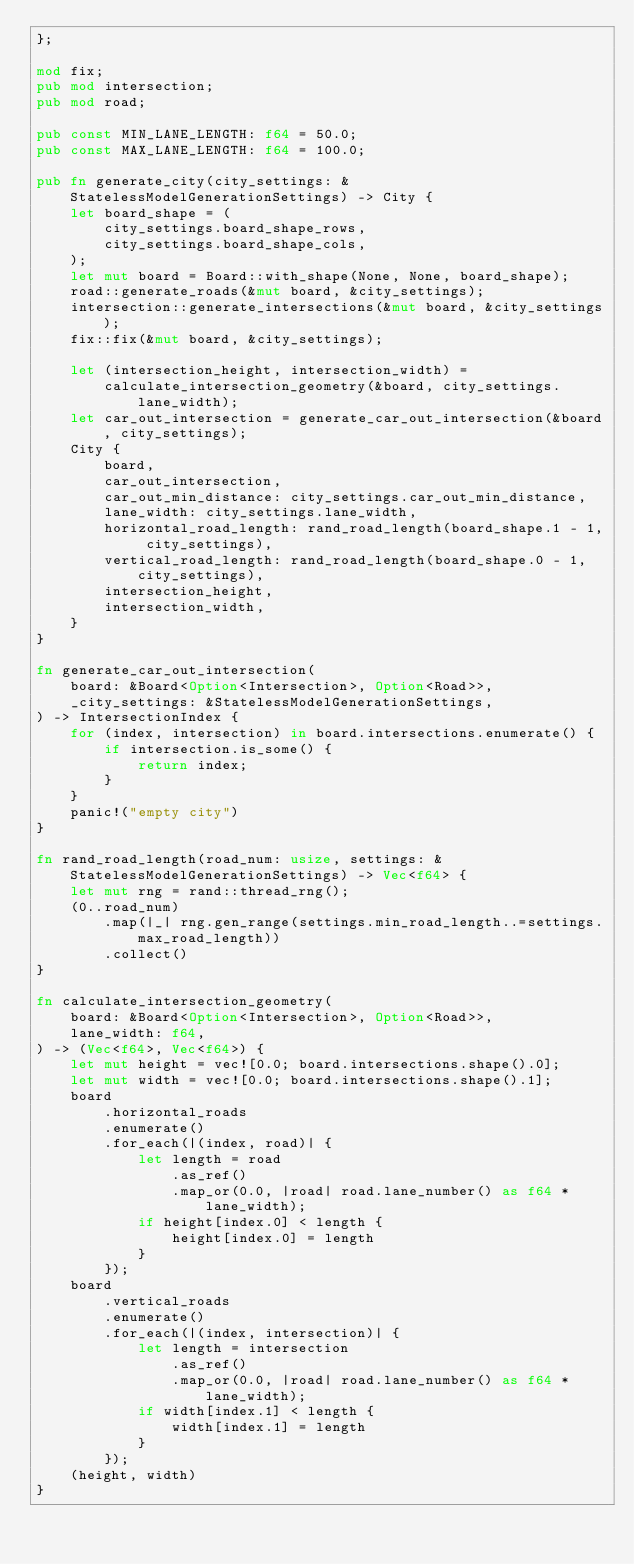Convert code to text. <code><loc_0><loc_0><loc_500><loc_500><_Rust_>};

mod fix;
pub mod intersection;
pub mod road;

pub const MIN_LANE_LENGTH: f64 = 50.0;
pub const MAX_LANE_LENGTH: f64 = 100.0;

pub fn generate_city(city_settings: &StatelessModelGenerationSettings) -> City {
    let board_shape = (
        city_settings.board_shape_rows,
        city_settings.board_shape_cols,
    );
    let mut board = Board::with_shape(None, None, board_shape);
    road::generate_roads(&mut board, &city_settings);
    intersection::generate_intersections(&mut board, &city_settings);
    fix::fix(&mut board, &city_settings);

    let (intersection_height, intersection_width) =
        calculate_intersection_geometry(&board, city_settings.lane_width);
    let car_out_intersection = generate_car_out_intersection(&board, city_settings);
    City {
        board,
        car_out_intersection,
        car_out_min_distance: city_settings.car_out_min_distance,
        lane_width: city_settings.lane_width,
        horizontal_road_length: rand_road_length(board_shape.1 - 1, city_settings),
        vertical_road_length: rand_road_length(board_shape.0 - 1, city_settings),
        intersection_height,
        intersection_width,
    }
}

fn generate_car_out_intersection(
    board: &Board<Option<Intersection>, Option<Road>>,
    _city_settings: &StatelessModelGenerationSettings,
) -> IntersectionIndex {
    for (index, intersection) in board.intersections.enumerate() {
        if intersection.is_some() {
            return index;
        }
    }
    panic!("empty city")
}

fn rand_road_length(road_num: usize, settings: &StatelessModelGenerationSettings) -> Vec<f64> {
    let mut rng = rand::thread_rng();
    (0..road_num)
        .map(|_| rng.gen_range(settings.min_road_length..=settings.max_road_length))
        .collect()
}

fn calculate_intersection_geometry(
    board: &Board<Option<Intersection>, Option<Road>>,
    lane_width: f64,
) -> (Vec<f64>, Vec<f64>) {
    let mut height = vec![0.0; board.intersections.shape().0];
    let mut width = vec![0.0; board.intersections.shape().1];
    board
        .horizontal_roads
        .enumerate()
        .for_each(|(index, road)| {
            let length = road
                .as_ref()
                .map_or(0.0, |road| road.lane_number() as f64 * lane_width);
            if height[index.0] < length {
                height[index.0] = length
            }
        });
    board
        .vertical_roads
        .enumerate()
        .for_each(|(index, intersection)| {
            let length = intersection
                .as_ref()
                .map_or(0.0, |road| road.lane_number() as f64 * lane_width);
            if width[index.1] < length {
                width[index.1] = length
            }
        });
    (height, width)
}
</code> 